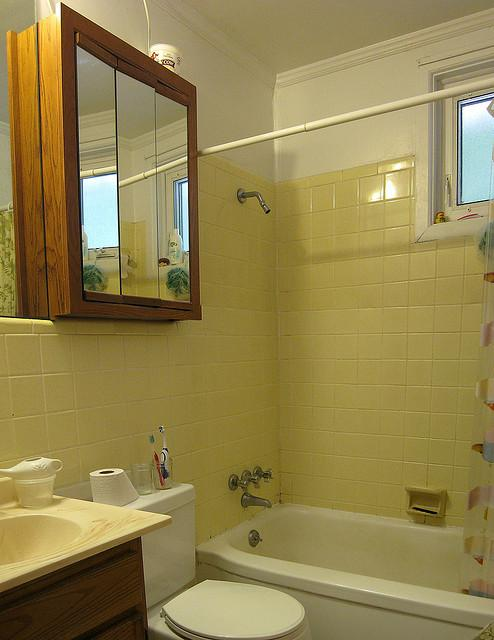Why is the toilet paper on the toilet tank?

Choices:
A) bidet
B) decoration
C) no holder
D) forgotten no holder 